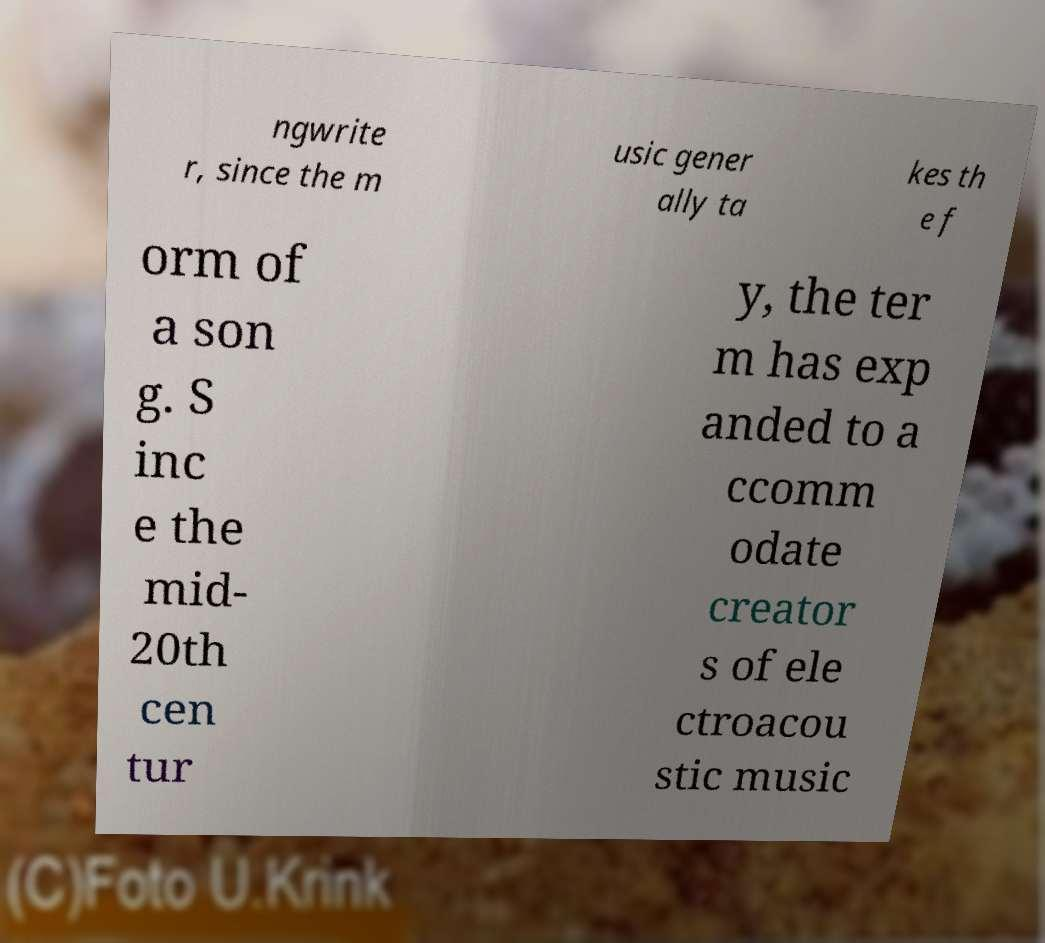Could you extract and type out the text from this image? ngwrite r, since the m usic gener ally ta kes th e f orm of a son g. S inc e the mid- 20th cen tur y, the ter m has exp anded to a ccomm odate creator s of ele ctroacou stic music 